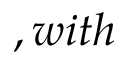<formula> <loc_0><loc_0><loc_500><loc_500>, w i t h</formula> 